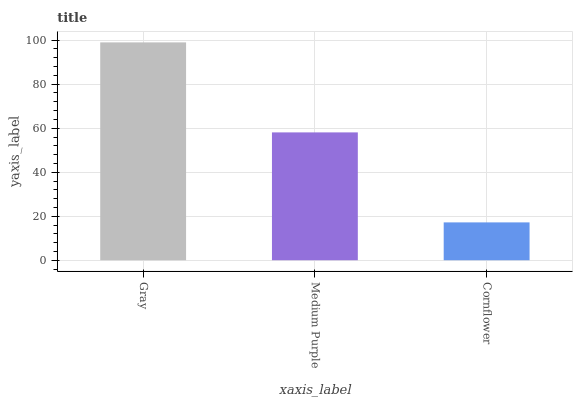Is Cornflower the minimum?
Answer yes or no. Yes. Is Gray the maximum?
Answer yes or no. Yes. Is Medium Purple the minimum?
Answer yes or no. No. Is Medium Purple the maximum?
Answer yes or no. No. Is Gray greater than Medium Purple?
Answer yes or no. Yes. Is Medium Purple less than Gray?
Answer yes or no. Yes. Is Medium Purple greater than Gray?
Answer yes or no. No. Is Gray less than Medium Purple?
Answer yes or no. No. Is Medium Purple the high median?
Answer yes or no. Yes. Is Medium Purple the low median?
Answer yes or no. Yes. Is Cornflower the high median?
Answer yes or no. No. Is Cornflower the low median?
Answer yes or no. No. 